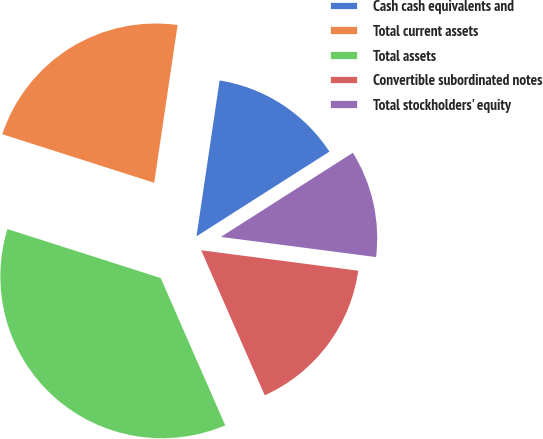Convert chart to OTSL. <chart><loc_0><loc_0><loc_500><loc_500><pie_chart><fcel>Cash cash equivalents and<fcel>Total current assets<fcel>Total assets<fcel>Convertible subordinated notes<fcel>Total stockholders' equity<nl><fcel>13.63%<fcel>22.42%<fcel>36.5%<fcel>16.37%<fcel>11.09%<nl></chart> 